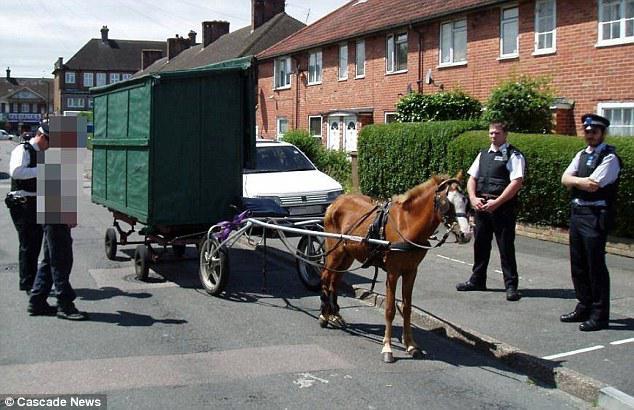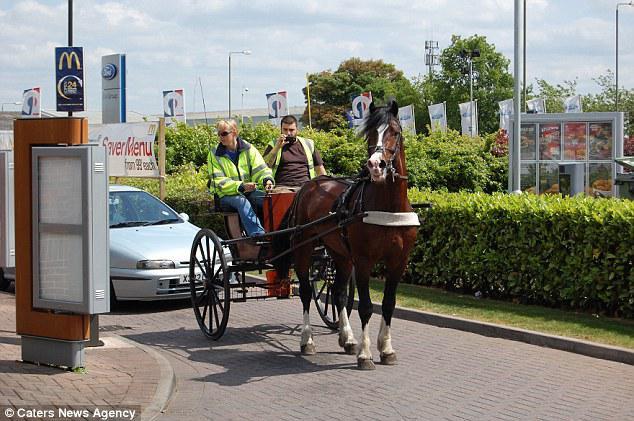The first image is the image on the left, the second image is the image on the right. Examine the images to the left and right. Is the description "a brown horse pulls a small carriage with 2 people on it" accurate? Answer yes or no. Yes. The first image is the image on the left, the second image is the image on the right. Given the left and right images, does the statement "Right image shows a four-wheeled cart puled by one horse." hold true? Answer yes or no. No. 